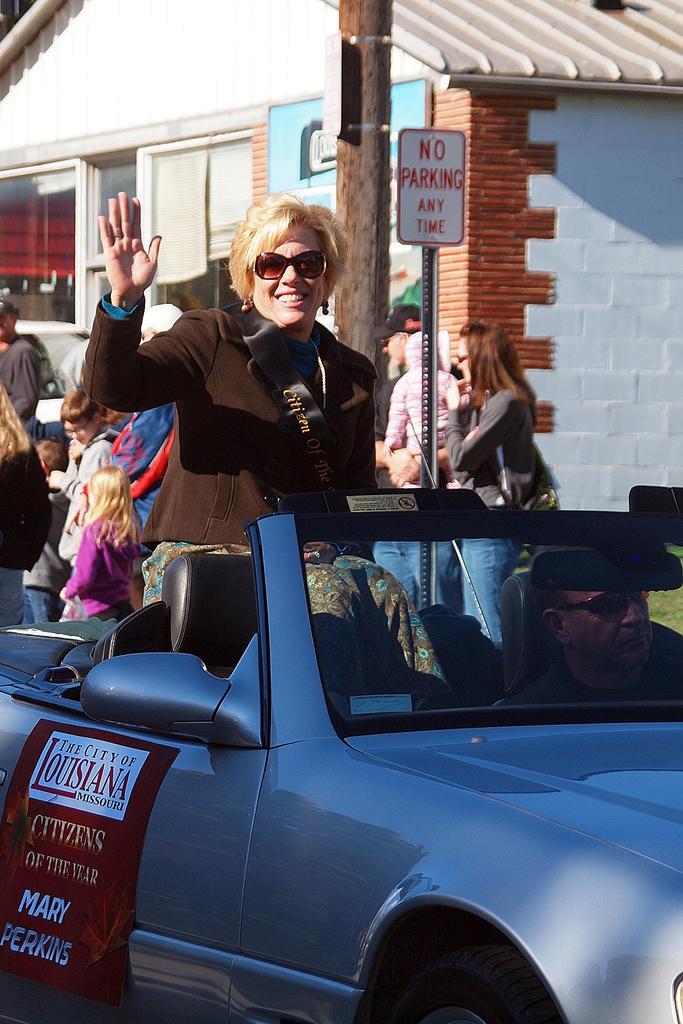Describe this image in one or two sentences. a person is standing in a car wearing a brown suit and goggles. in the front a person is riding the car. behind them there are people standing. at the center there is no parking board and a pole. behind that there is a building which is white in color. 